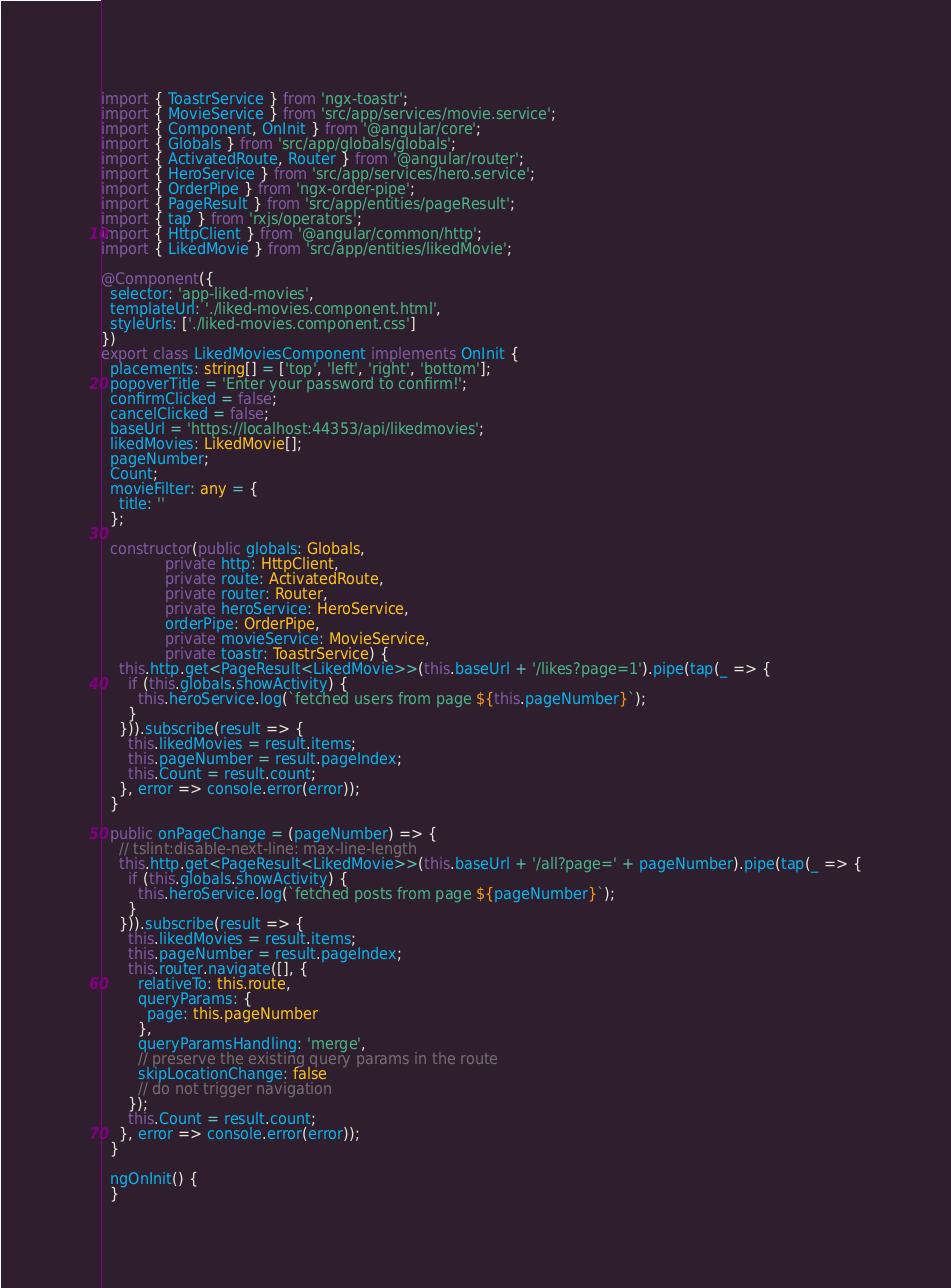<code> <loc_0><loc_0><loc_500><loc_500><_TypeScript_>import { ToastrService } from 'ngx-toastr';
import { MovieService } from 'src/app/services/movie.service';
import { Component, OnInit } from '@angular/core';
import { Globals } from 'src/app/globals/globals';
import { ActivatedRoute, Router } from '@angular/router';
import { HeroService } from 'src/app/services/hero.service';
import { OrderPipe } from 'ngx-order-pipe';
import { PageResult } from 'src/app/entities/pageResult';
import { tap } from 'rxjs/operators';
import { HttpClient } from '@angular/common/http';
import { LikedMovie } from 'src/app/entities/likedMovie';

@Component({
  selector: 'app-liked-movies',
  templateUrl: './liked-movies.component.html',
  styleUrls: ['./liked-movies.component.css']
})
export class LikedMoviesComponent implements OnInit {
  placements: string[] = ['top', 'left', 'right', 'bottom'];
  popoverTitle = 'Enter your password to confirm!';
  confirmClicked = false;
  cancelClicked = false;
  baseUrl = 'https://localhost:44353/api/likedmovies';
  likedMovies: LikedMovie[];
  pageNumber;
  Count;
  movieFilter: any = {
    title: ''
  };

  constructor(public globals: Globals,
              private http: HttpClient,
              private route: ActivatedRoute,
              private router: Router,
              private heroService: HeroService,
              orderPipe: OrderPipe,
              private movieService: MovieService,
              private toastr: ToastrService) {
    this.http.get<PageResult<LikedMovie>>(this.baseUrl + '/likes?page=1').pipe(tap(_ => {
      if (this.globals.showActivity) {
        this.heroService.log(`fetched users from page ${this.pageNumber}`);
      }
    })).subscribe(result => {
      this.likedMovies = result.items;
      this.pageNumber = result.pageIndex;
      this.Count = result.count;
    }, error => console.error(error));
  }

  public onPageChange = (pageNumber) => {
    // tslint:disable-next-line: max-line-length
    this.http.get<PageResult<LikedMovie>>(this.baseUrl + '/all?page=' + pageNumber).pipe(tap(_ => {
      if (this.globals.showActivity) {
        this.heroService.log(`fetched posts from page ${pageNumber}`);
      }
    })).subscribe(result => {
      this.likedMovies = result.items;
      this.pageNumber = result.pageIndex;
      this.router.navigate([], {
        relativeTo: this.route,
        queryParams: {
          page: this.pageNumber
        },
        queryParamsHandling: 'merge',
        // preserve the existing query params in the route
        skipLocationChange: false
        // do not trigger navigation
      });
      this.Count = result.count;
    }, error => console.error(error));
  }

  ngOnInit() {
  }
</code> 